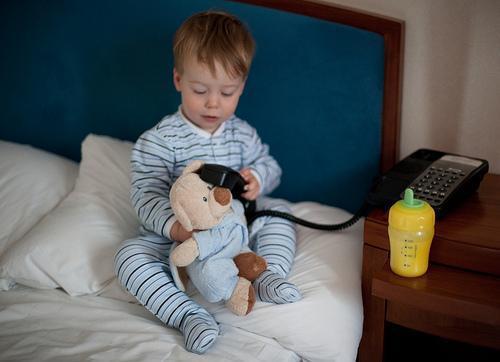How many children are there?
Give a very brief answer. 1. 